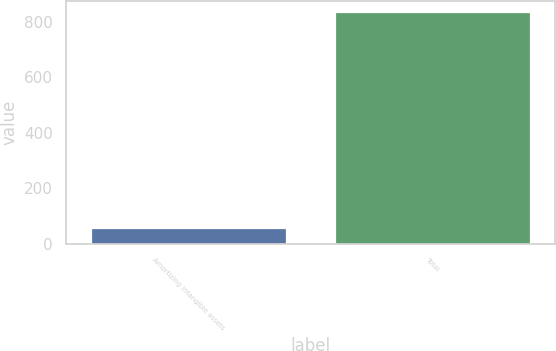<chart> <loc_0><loc_0><loc_500><loc_500><bar_chart><fcel>Amortizing intangible assets<fcel>Total<nl><fcel>55.2<fcel>833.5<nl></chart> 